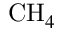<formula> <loc_0><loc_0><loc_500><loc_500>C H _ { 4 }</formula> 